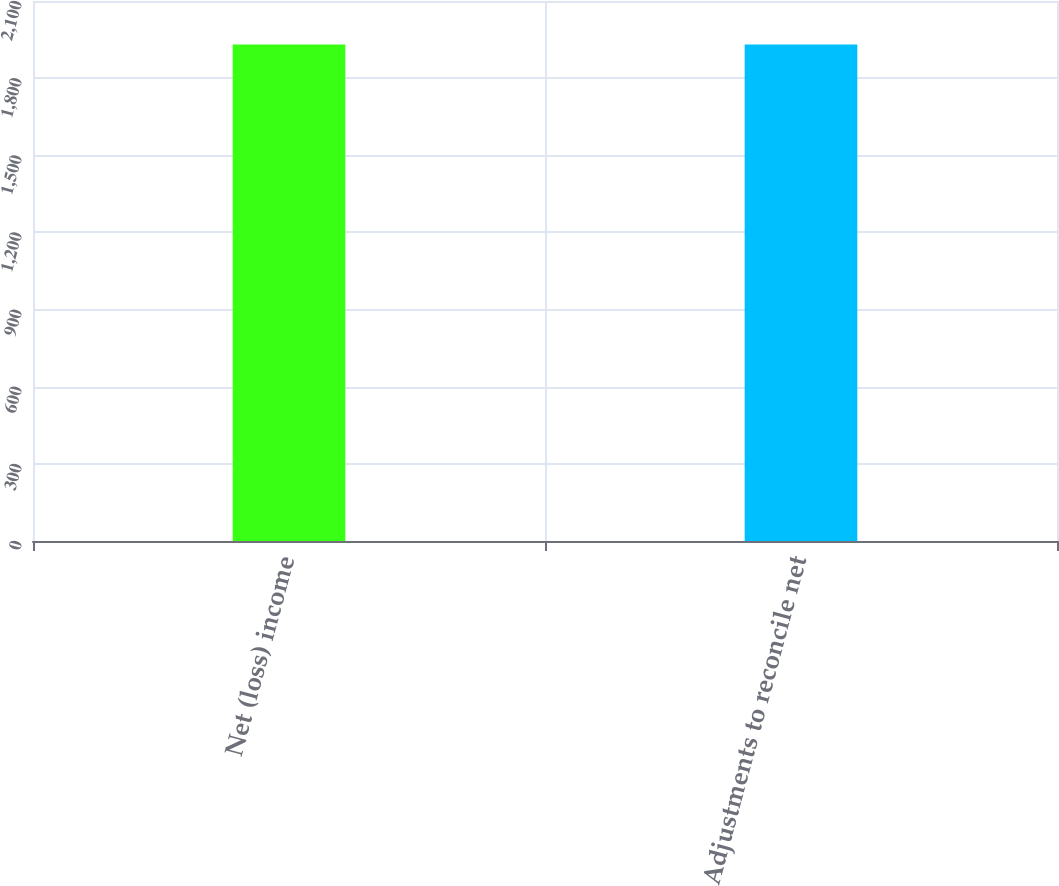<chart> <loc_0><loc_0><loc_500><loc_500><bar_chart><fcel>Net (loss) income<fcel>Adjustments to reconcile net<nl><fcel>1931<fcel>1931.1<nl></chart> 